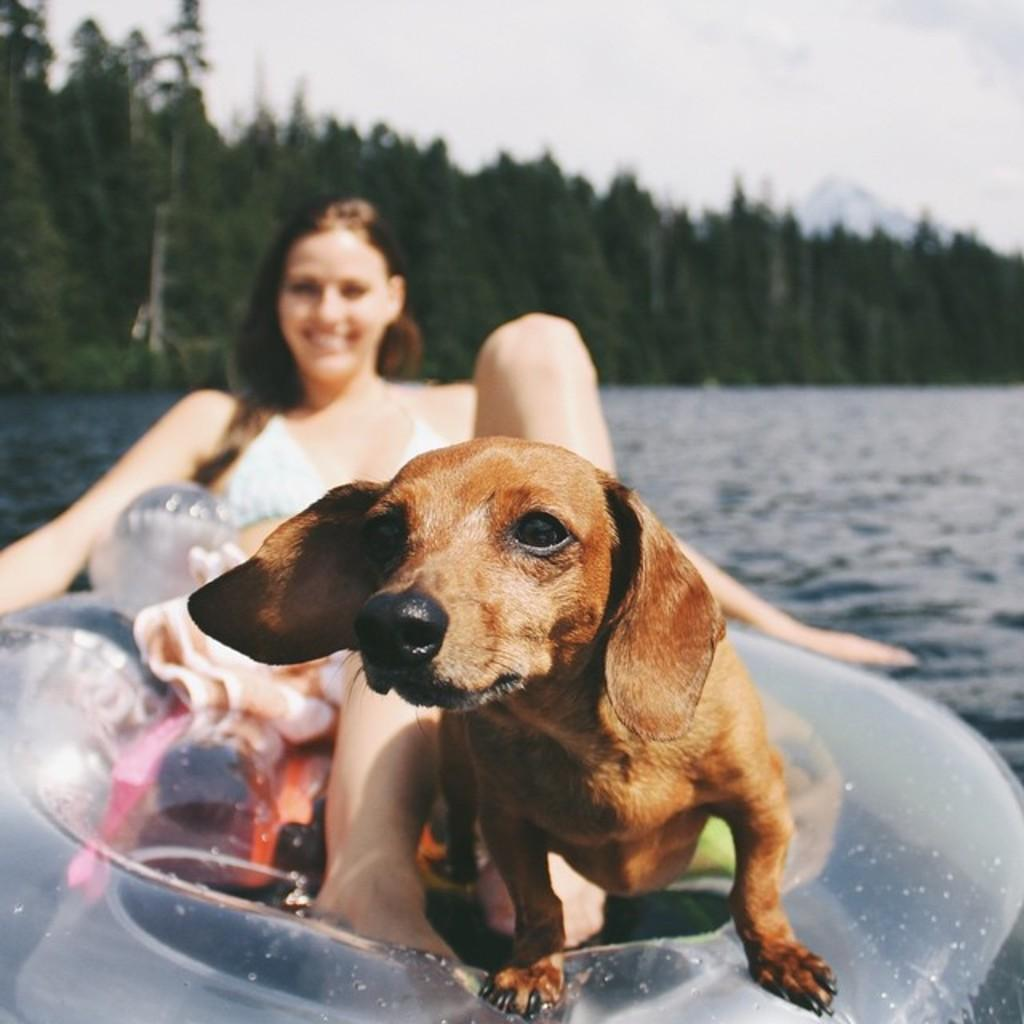Who is present in the image? There is a woman in the image. What other living creature is present in the image? There is a dog in the image. Can you describe the dog's appearance? The dog is brown. Where are the woman and the dog located in the image? The woman and the dog are on a boat. What can be seen in the background of the image? There is water and trees visible in the image. How is the woman feeling in the image? The woman is smiling. How many socks is the dog wearing in the image? There are no socks visible in the image, as the dog is a brown dog on a boat with a woman. Can you tell me how many horses are present in the image? There are no horses present in the image; it features a woman and a brown dog on a boat. 